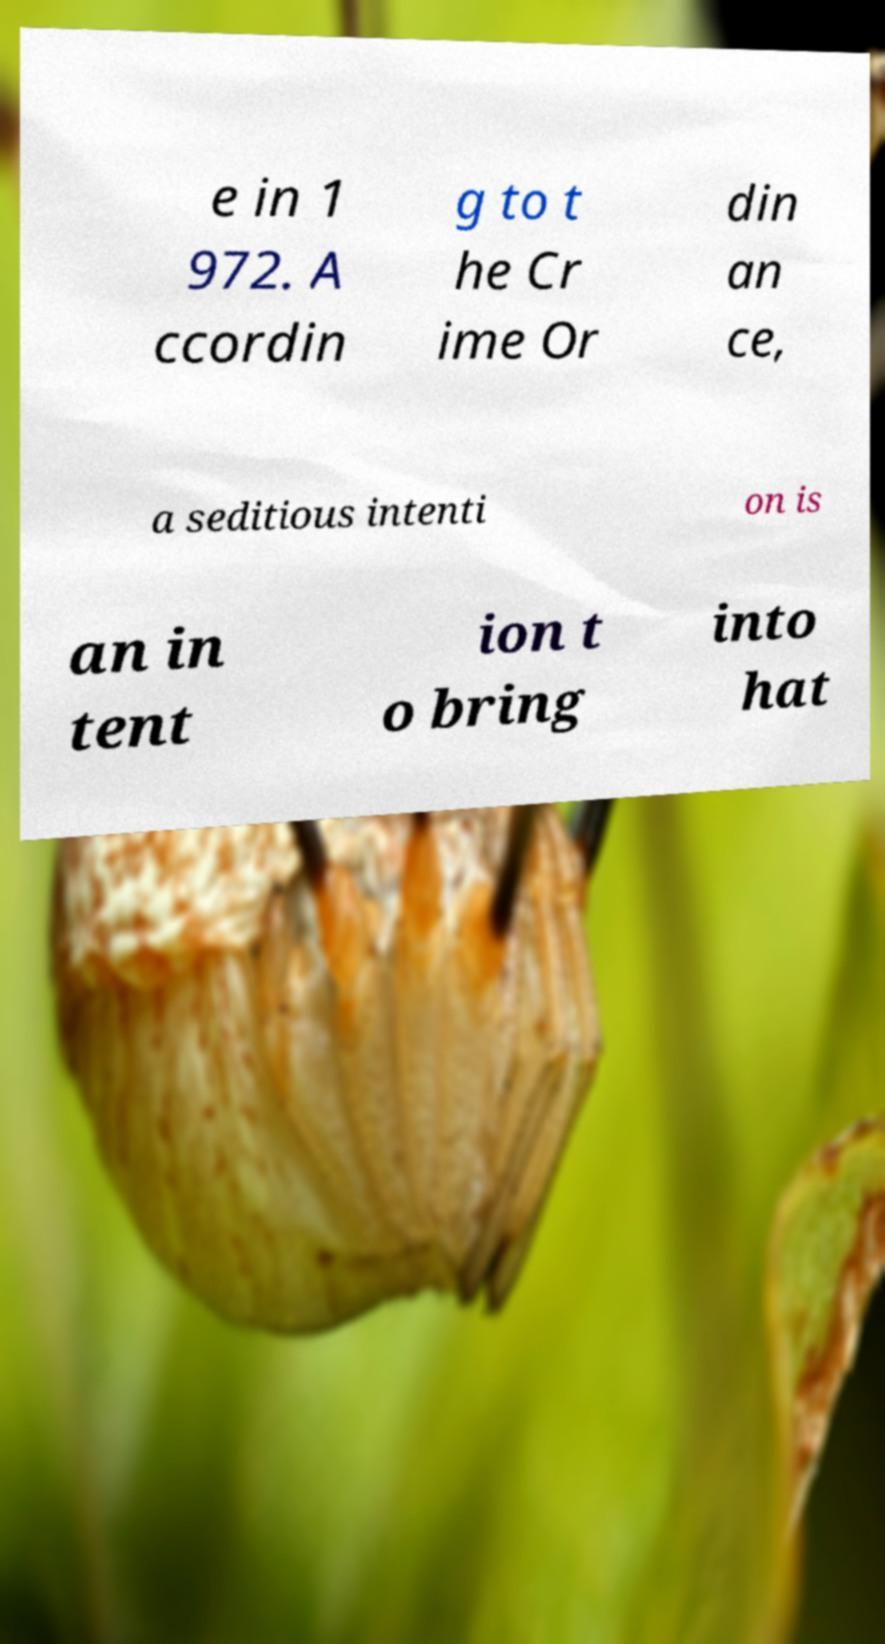Please read and relay the text visible in this image. What does it say? e in 1 972. A ccordin g to t he Cr ime Or din an ce, a seditious intenti on is an in tent ion t o bring into hat 